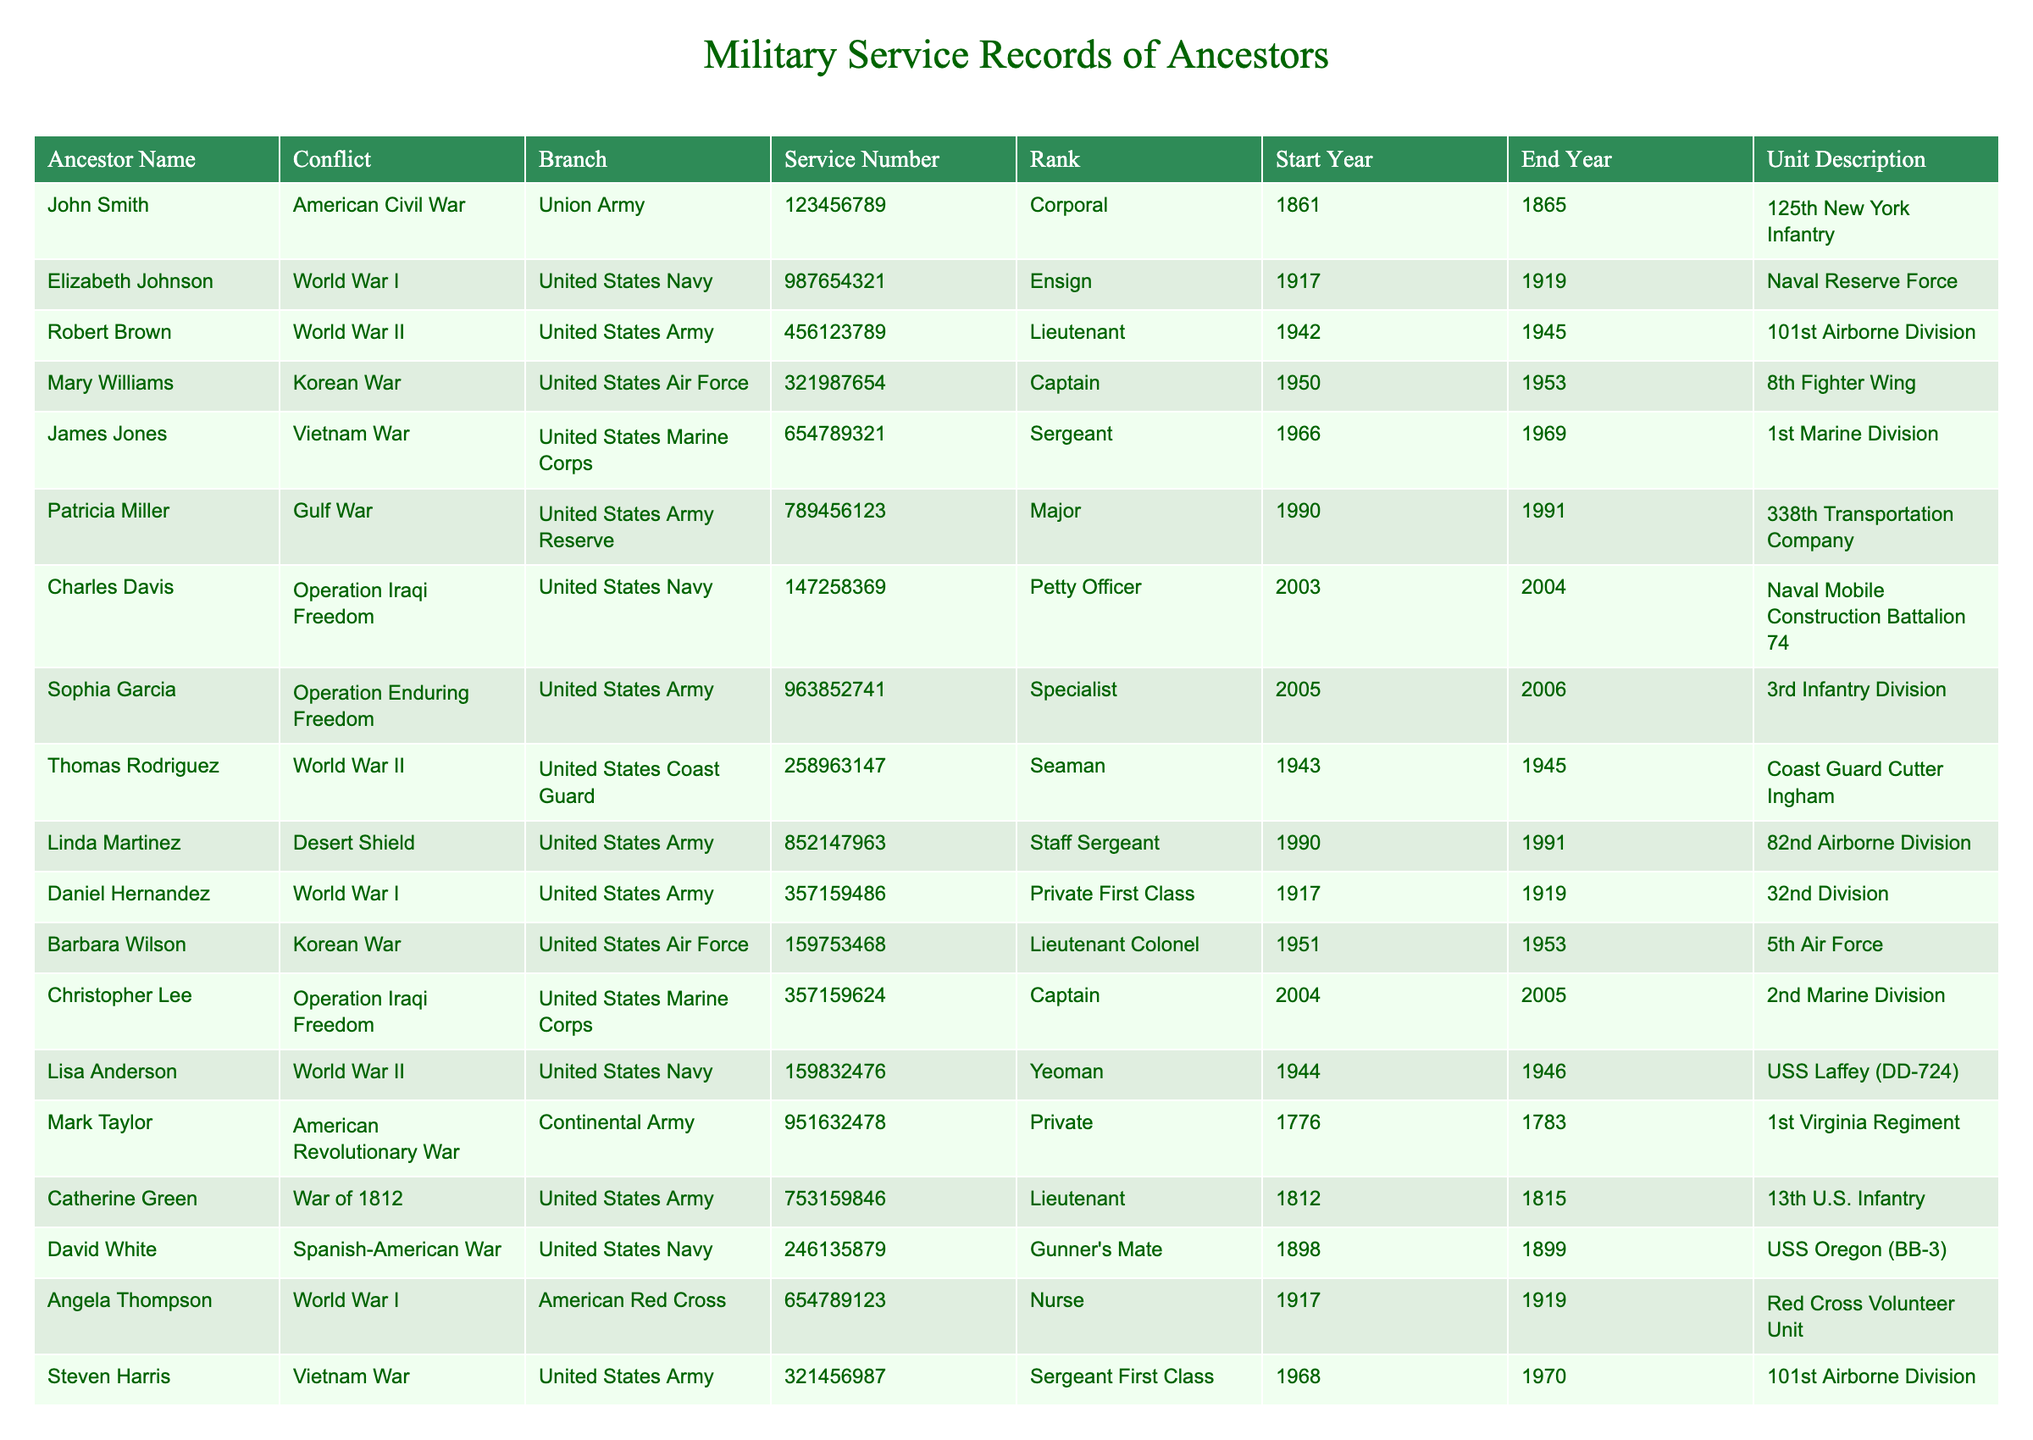What is the rank of John Smith? John Smith’s entry in the table lists his rank as Corporal.
Answer: Corporal Which ancestor served in the United States Navy during World War I? The table shows that Elizabeth Johnson served in the United States Navy during World War I with the rank of Ensign.
Answer: Elizabeth Johnson How many ancestors served in the Korean War? The table lists two ancestors, Mary Williams and Barbara Wilson, who served during the Korean War.
Answer: 2 What years did Robert Brown serve in World War II? The table indicates that Robert Brown served from 1942 to 1945 in World War II.
Answer: 1942 to 1945 Did any ancestors serve in both World War I and World War II? By checking the table, we see that Daniel Hernandez served in World War I and Robert Brown served in World War II. They are different ancestors, so the answer is no.
Answer: No Which branch had the most ancestors serving during the conflicts listed? If we count the occurrences by branch in the table, the United States Army has the most entries, specifically 6 ancestors.
Answer: United States Army Who was the highest-ranking ancestor in the table? We need to compare ranks across the table. Barbara Wilson is a Lieutenant Colonel, which is higher than any other rank listed.
Answer: Lieutenant Colonel What was the service number of Charles Davis? Looking at the entry for Charles Davis, his service number is 147258369.
Answer: 147258369 How many conflicts were represented by the ancestors in the table? Counting the unique conflicts listed in the table, we find there are 10 distinct conflicts.
Answer: 10 Did any ancestor serve in the United States Coast Guard? Yes, the table shows that Thomas Rodriguez served in the United States Coast Guard during World War II.
Answer: Yes What was the duration of service for Patricia Miller in the Gulf War? Patricia Miller's entry shows she served from 1990 to 1991, which is 1 year.
Answer: 1 year Between which years did the most recent ancestor serve? The most recent service listed in the table is for Susan Clark, who served from 2006 to 2007.
Answer: 2006 to 2007 Who served as a nurse during World War I? According to the table, Angela Thompson served as a nurse with the American Red Cross during World War I.
Answer: Angela Thompson Which ancestor served in the 8th Fighter Wing during the Korean War? The table specifies that Mary Williams served in the 8th Fighter Wing during the Korean War.
Answer: Mary Williams What is the average rank of ancestors who served in the United States Army? The ranks for the United States Army listed in the table are Private First Class, Captain, Sergeant, and Specialist. If we assign numerical values based on rank (Private First Class = 1, Captain = 4, Sergeant = 3, Specialist = 2), the average rank would be calculated as (1+4+3+2)/4 = 2.5, which corresponds to Specialist.
Answer: Specialist How many years did David White serve in the Spanish-American War? The table indicates David White served from 1898 to 1899, so he served for 1 year.
Answer: 1 year 